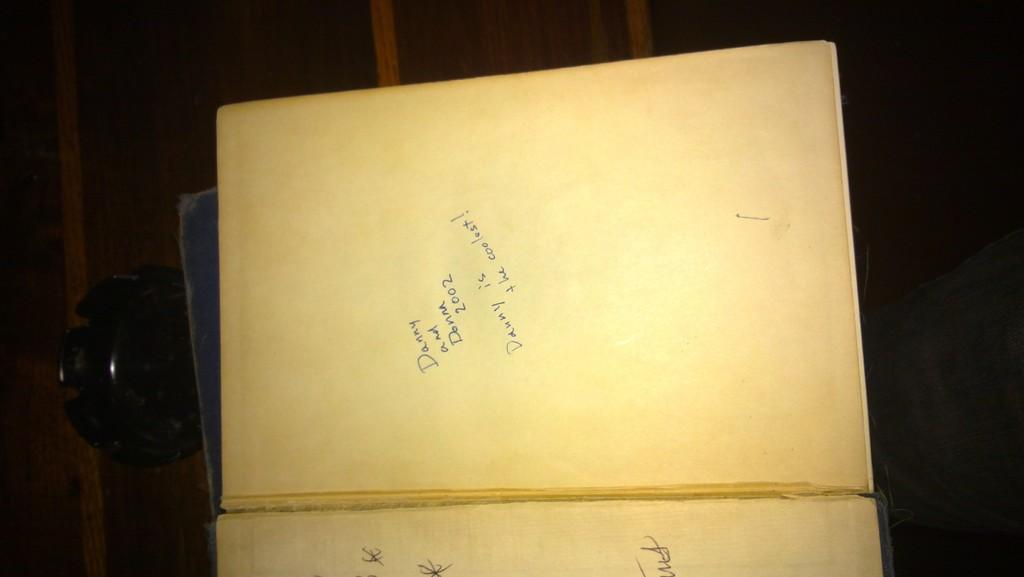<image>
Provide a brief description of the given image. A book was given to Danny and Donna in 2002. 